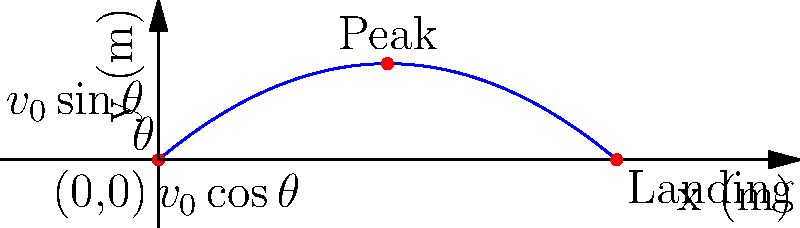A soccer player kicks a ball with an initial velocity of 25 m/s at an angle of 40° above the horizontal. Using the coordinate system shown in the diagram, calculate:
a) The maximum height reached by the ball
b) The total horizontal distance traveled by the ball
c) The time taken for the ball to reach its maximum height

Assume air resistance is negligible and use g = 9.8 m/s². Let's approach this step-by-step using the equations of motion for projectile motion.

Given:
- Initial velocity, $v_0 = 25$ m/s
- Angle of projection, $\theta = 40°$
- Acceleration due to gravity, $g = 9.8$ m/s²

Step 1: Resolve the initial velocity into its x and y components.
$v_{0x} = v_0 \cos\theta = 25 \cos 40° = 19.15$ m/s
$v_{0y} = v_0 \sin\theta = 25 \sin 40° = 16.07$ m/s

a) To find the maximum height:
Use the equation: $y_{max} = \frac{v_{0y}^2}{2g}$
$y_{max} = \frac{(16.07)^2}{2(9.8)} = 13.18$ m

b) To find the total horizontal distance:
Use the equation: $x_{max} = \frac{2v_0^2\sin\theta\cos\theta}{g}$
$x_{max} = \frac{2(25)^2\sin 40°\cos 40°}{9.8} = 51.53$ m

c) To find the time to reach maximum height:
Use the equation: $t_{peak} = \frac{v_{0y}}{g}$
$t_{peak} = \frac{16.07}{9.8} = 1.64$ s

Note: The total time of flight would be twice this value, as the time to go up equals the time to come down in the absence of air resistance.
Answer: a) 13.18 m
b) 51.53 m
c) 1.64 s 